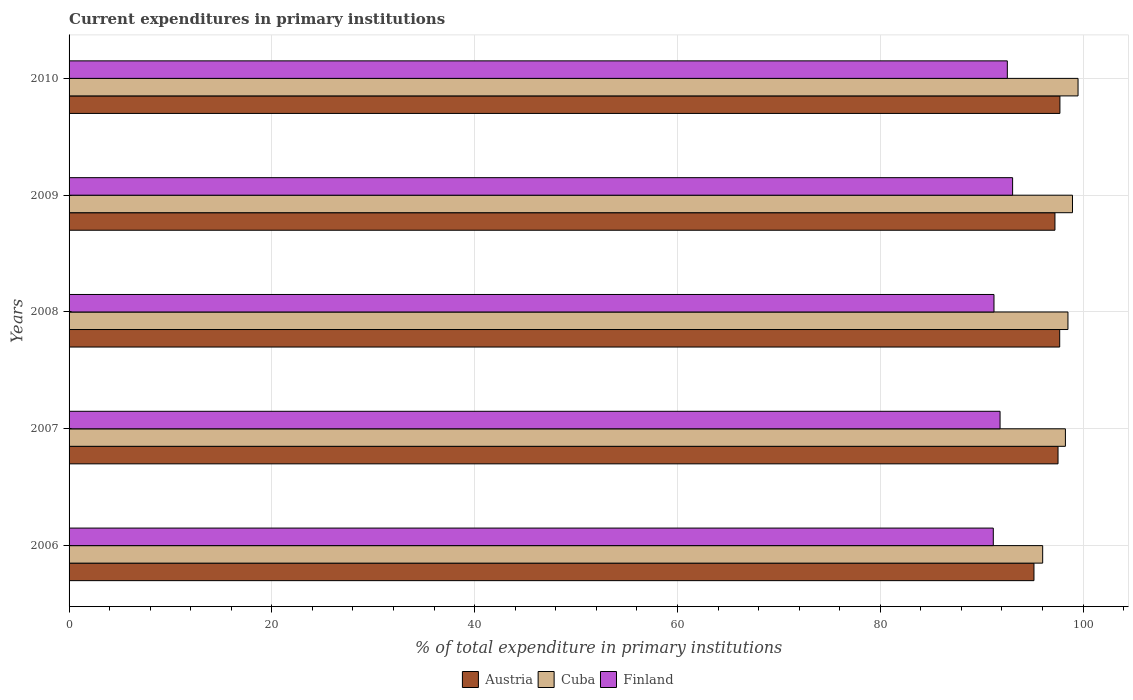Are the number of bars per tick equal to the number of legend labels?
Ensure brevity in your answer.  Yes. What is the current expenditures in primary institutions in Austria in 2006?
Give a very brief answer. 95.16. Across all years, what is the maximum current expenditures in primary institutions in Austria?
Offer a terse response. 97.72. Across all years, what is the minimum current expenditures in primary institutions in Austria?
Offer a terse response. 95.16. What is the total current expenditures in primary institutions in Cuba in the graph?
Provide a short and direct response. 491.24. What is the difference between the current expenditures in primary institutions in Cuba in 2006 and that in 2007?
Make the answer very short. -2.24. What is the difference between the current expenditures in primary institutions in Finland in 2006 and the current expenditures in primary institutions in Cuba in 2009?
Your answer should be compact. -7.81. What is the average current expenditures in primary institutions in Finland per year?
Your response must be concise. 91.95. In the year 2010, what is the difference between the current expenditures in primary institutions in Austria and current expenditures in primary institutions in Finland?
Make the answer very short. 5.19. In how many years, is the current expenditures in primary institutions in Finland greater than 84 %?
Offer a very short reply. 5. What is the ratio of the current expenditures in primary institutions in Cuba in 2006 to that in 2010?
Keep it short and to the point. 0.96. Is the difference between the current expenditures in primary institutions in Austria in 2007 and 2010 greater than the difference between the current expenditures in primary institutions in Finland in 2007 and 2010?
Ensure brevity in your answer.  Yes. What is the difference between the highest and the second highest current expenditures in primary institutions in Finland?
Provide a short and direct response. 0.52. What is the difference between the highest and the lowest current expenditures in primary institutions in Austria?
Your answer should be very brief. 2.56. In how many years, is the current expenditures in primary institutions in Austria greater than the average current expenditures in primary institutions in Austria taken over all years?
Offer a very short reply. 4. Is the sum of the current expenditures in primary institutions in Cuba in 2007 and 2009 greater than the maximum current expenditures in primary institutions in Finland across all years?
Offer a very short reply. Yes. What does the 2nd bar from the top in 2007 represents?
Your response must be concise. Cuba. What does the 3rd bar from the bottom in 2009 represents?
Give a very brief answer. Finland. Is it the case that in every year, the sum of the current expenditures in primary institutions in Austria and current expenditures in primary institutions in Cuba is greater than the current expenditures in primary institutions in Finland?
Offer a terse response. Yes. Are all the bars in the graph horizontal?
Your answer should be compact. Yes. How many years are there in the graph?
Provide a short and direct response. 5. What is the difference between two consecutive major ticks on the X-axis?
Ensure brevity in your answer.  20. Does the graph contain grids?
Provide a succinct answer. Yes. What is the title of the graph?
Offer a very short reply. Current expenditures in primary institutions. What is the label or title of the X-axis?
Keep it short and to the point. % of total expenditure in primary institutions. What is the label or title of the Y-axis?
Give a very brief answer. Years. What is the % of total expenditure in primary institutions in Austria in 2006?
Provide a succinct answer. 95.16. What is the % of total expenditure in primary institutions of Cuba in 2006?
Offer a very short reply. 96.02. What is the % of total expenditure in primary institutions in Finland in 2006?
Your response must be concise. 91.15. What is the % of total expenditure in primary institutions in Austria in 2007?
Keep it short and to the point. 97.53. What is the % of total expenditure in primary institutions of Cuba in 2007?
Your answer should be compact. 98.26. What is the % of total expenditure in primary institutions in Finland in 2007?
Offer a terse response. 91.81. What is the % of total expenditure in primary institutions in Austria in 2008?
Offer a terse response. 97.7. What is the % of total expenditure in primary institutions in Cuba in 2008?
Your answer should be compact. 98.51. What is the % of total expenditure in primary institutions in Finland in 2008?
Offer a very short reply. 91.21. What is the % of total expenditure in primary institutions of Austria in 2009?
Ensure brevity in your answer.  97.23. What is the % of total expenditure in primary institutions in Cuba in 2009?
Ensure brevity in your answer.  98.96. What is the % of total expenditure in primary institutions in Finland in 2009?
Give a very brief answer. 93.05. What is the % of total expenditure in primary institutions in Austria in 2010?
Make the answer very short. 97.72. What is the % of total expenditure in primary institutions in Cuba in 2010?
Provide a short and direct response. 99.5. What is the % of total expenditure in primary institutions in Finland in 2010?
Your response must be concise. 92.53. Across all years, what is the maximum % of total expenditure in primary institutions in Austria?
Ensure brevity in your answer.  97.72. Across all years, what is the maximum % of total expenditure in primary institutions of Cuba?
Provide a short and direct response. 99.5. Across all years, what is the maximum % of total expenditure in primary institutions in Finland?
Make the answer very short. 93.05. Across all years, what is the minimum % of total expenditure in primary institutions of Austria?
Offer a very short reply. 95.16. Across all years, what is the minimum % of total expenditure in primary institutions of Cuba?
Your response must be concise. 96.02. Across all years, what is the minimum % of total expenditure in primary institutions of Finland?
Provide a short and direct response. 91.15. What is the total % of total expenditure in primary institutions in Austria in the graph?
Offer a very short reply. 485.33. What is the total % of total expenditure in primary institutions in Cuba in the graph?
Give a very brief answer. 491.24. What is the total % of total expenditure in primary institutions of Finland in the graph?
Offer a very short reply. 459.75. What is the difference between the % of total expenditure in primary institutions in Austria in 2006 and that in 2007?
Provide a succinct answer. -2.37. What is the difference between the % of total expenditure in primary institutions in Cuba in 2006 and that in 2007?
Your response must be concise. -2.24. What is the difference between the % of total expenditure in primary institutions of Finland in 2006 and that in 2007?
Provide a succinct answer. -0.67. What is the difference between the % of total expenditure in primary institutions of Austria in 2006 and that in 2008?
Offer a very short reply. -2.54. What is the difference between the % of total expenditure in primary institutions of Cuba in 2006 and that in 2008?
Your answer should be very brief. -2.49. What is the difference between the % of total expenditure in primary institutions of Finland in 2006 and that in 2008?
Your answer should be very brief. -0.07. What is the difference between the % of total expenditure in primary institutions of Austria in 2006 and that in 2009?
Make the answer very short. -2.07. What is the difference between the % of total expenditure in primary institutions in Cuba in 2006 and that in 2009?
Your response must be concise. -2.94. What is the difference between the % of total expenditure in primary institutions in Finland in 2006 and that in 2009?
Ensure brevity in your answer.  -1.9. What is the difference between the % of total expenditure in primary institutions in Austria in 2006 and that in 2010?
Your answer should be compact. -2.56. What is the difference between the % of total expenditure in primary institutions of Cuba in 2006 and that in 2010?
Provide a short and direct response. -3.49. What is the difference between the % of total expenditure in primary institutions of Finland in 2006 and that in 2010?
Provide a succinct answer. -1.38. What is the difference between the % of total expenditure in primary institutions of Austria in 2007 and that in 2008?
Keep it short and to the point. -0.17. What is the difference between the % of total expenditure in primary institutions of Cuba in 2007 and that in 2008?
Make the answer very short. -0.25. What is the difference between the % of total expenditure in primary institutions of Finland in 2007 and that in 2008?
Keep it short and to the point. 0.6. What is the difference between the % of total expenditure in primary institutions in Austria in 2007 and that in 2009?
Provide a short and direct response. 0.3. What is the difference between the % of total expenditure in primary institutions of Cuba in 2007 and that in 2009?
Offer a terse response. -0.7. What is the difference between the % of total expenditure in primary institutions of Finland in 2007 and that in 2009?
Your answer should be compact. -1.24. What is the difference between the % of total expenditure in primary institutions of Austria in 2007 and that in 2010?
Keep it short and to the point. -0.19. What is the difference between the % of total expenditure in primary institutions in Cuba in 2007 and that in 2010?
Your response must be concise. -1.25. What is the difference between the % of total expenditure in primary institutions in Finland in 2007 and that in 2010?
Ensure brevity in your answer.  -0.72. What is the difference between the % of total expenditure in primary institutions of Austria in 2008 and that in 2009?
Provide a short and direct response. 0.47. What is the difference between the % of total expenditure in primary institutions in Cuba in 2008 and that in 2009?
Offer a very short reply. -0.45. What is the difference between the % of total expenditure in primary institutions in Finland in 2008 and that in 2009?
Keep it short and to the point. -1.84. What is the difference between the % of total expenditure in primary institutions of Austria in 2008 and that in 2010?
Keep it short and to the point. -0.02. What is the difference between the % of total expenditure in primary institutions of Cuba in 2008 and that in 2010?
Provide a short and direct response. -0.99. What is the difference between the % of total expenditure in primary institutions in Finland in 2008 and that in 2010?
Provide a succinct answer. -1.32. What is the difference between the % of total expenditure in primary institutions of Austria in 2009 and that in 2010?
Make the answer very short. -0.49. What is the difference between the % of total expenditure in primary institutions of Cuba in 2009 and that in 2010?
Offer a very short reply. -0.55. What is the difference between the % of total expenditure in primary institutions in Finland in 2009 and that in 2010?
Ensure brevity in your answer.  0.52. What is the difference between the % of total expenditure in primary institutions in Austria in 2006 and the % of total expenditure in primary institutions in Cuba in 2007?
Offer a terse response. -3.1. What is the difference between the % of total expenditure in primary institutions in Austria in 2006 and the % of total expenditure in primary institutions in Finland in 2007?
Provide a succinct answer. 3.34. What is the difference between the % of total expenditure in primary institutions in Cuba in 2006 and the % of total expenditure in primary institutions in Finland in 2007?
Keep it short and to the point. 4.2. What is the difference between the % of total expenditure in primary institutions in Austria in 2006 and the % of total expenditure in primary institutions in Cuba in 2008?
Your answer should be very brief. -3.35. What is the difference between the % of total expenditure in primary institutions of Austria in 2006 and the % of total expenditure in primary institutions of Finland in 2008?
Offer a terse response. 3.94. What is the difference between the % of total expenditure in primary institutions of Cuba in 2006 and the % of total expenditure in primary institutions of Finland in 2008?
Offer a terse response. 4.8. What is the difference between the % of total expenditure in primary institutions of Austria in 2006 and the % of total expenditure in primary institutions of Cuba in 2009?
Provide a short and direct response. -3.8. What is the difference between the % of total expenditure in primary institutions in Austria in 2006 and the % of total expenditure in primary institutions in Finland in 2009?
Ensure brevity in your answer.  2.11. What is the difference between the % of total expenditure in primary institutions in Cuba in 2006 and the % of total expenditure in primary institutions in Finland in 2009?
Ensure brevity in your answer.  2.97. What is the difference between the % of total expenditure in primary institutions of Austria in 2006 and the % of total expenditure in primary institutions of Cuba in 2010?
Keep it short and to the point. -4.35. What is the difference between the % of total expenditure in primary institutions in Austria in 2006 and the % of total expenditure in primary institutions in Finland in 2010?
Give a very brief answer. 2.63. What is the difference between the % of total expenditure in primary institutions of Cuba in 2006 and the % of total expenditure in primary institutions of Finland in 2010?
Offer a very short reply. 3.49. What is the difference between the % of total expenditure in primary institutions in Austria in 2007 and the % of total expenditure in primary institutions in Cuba in 2008?
Provide a succinct answer. -0.98. What is the difference between the % of total expenditure in primary institutions in Austria in 2007 and the % of total expenditure in primary institutions in Finland in 2008?
Offer a terse response. 6.32. What is the difference between the % of total expenditure in primary institutions of Cuba in 2007 and the % of total expenditure in primary institutions of Finland in 2008?
Your answer should be compact. 7.04. What is the difference between the % of total expenditure in primary institutions in Austria in 2007 and the % of total expenditure in primary institutions in Cuba in 2009?
Provide a succinct answer. -1.43. What is the difference between the % of total expenditure in primary institutions in Austria in 2007 and the % of total expenditure in primary institutions in Finland in 2009?
Ensure brevity in your answer.  4.48. What is the difference between the % of total expenditure in primary institutions of Cuba in 2007 and the % of total expenditure in primary institutions of Finland in 2009?
Give a very brief answer. 5.21. What is the difference between the % of total expenditure in primary institutions in Austria in 2007 and the % of total expenditure in primary institutions in Cuba in 2010?
Make the answer very short. -1.97. What is the difference between the % of total expenditure in primary institutions of Austria in 2007 and the % of total expenditure in primary institutions of Finland in 2010?
Give a very brief answer. 5. What is the difference between the % of total expenditure in primary institutions of Cuba in 2007 and the % of total expenditure in primary institutions of Finland in 2010?
Make the answer very short. 5.73. What is the difference between the % of total expenditure in primary institutions of Austria in 2008 and the % of total expenditure in primary institutions of Cuba in 2009?
Your answer should be very brief. -1.26. What is the difference between the % of total expenditure in primary institutions in Austria in 2008 and the % of total expenditure in primary institutions in Finland in 2009?
Offer a terse response. 4.64. What is the difference between the % of total expenditure in primary institutions of Cuba in 2008 and the % of total expenditure in primary institutions of Finland in 2009?
Your response must be concise. 5.46. What is the difference between the % of total expenditure in primary institutions in Austria in 2008 and the % of total expenditure in primary institutions in Cuba in 2010?
Offer a very short reply. -1.81. What is the difference between the % of total expenditure in primary institutions in Austria in 2008 and the % of total expenditure in primary institutions in Finland in 2010?
Your response must be concise. 5.16. What is the difference between the % of total expenditure in primary institutions of Cuba in 2008 and the % of total expenditure in primary institutions of Finland in 2010?
Ensure brevity in your answer.  5.98. What is the difference between the % of total expenditure in primary institutions of Austria in 2009 and the % of total expenditure in primary institutions of Cuba in 2010?
Keep it short and to the point. -2.28. What is the difference between the % of total expenditure in primary institutions in Austria in 2009 and the % of total expenditure in primary institutions in Finland in 2010?
Make the answer very short. 4.7. What is the difference between the % of total expenditure in primary institutions of Cuba in 2009 and the % of total expenditure in primary institutions of Finland in 2010?
Your answer should be compact. 6.42. What is the average % of total expenditure in primary institutions in Austria per year?
Provide a short and direct response. 97.07. What is the average % of total expenditure in primary institutions of Cuba per year?
Your response must be concise. 98.25. What is the average % of total expenditure in primary institutions of Finland per year?
Give a very brief answer. 91.95. In the year 2006, what is the difference between the % of total expenditure in primary institutions in Austria and % of total expenditure in primary institutions in Cuba?
Keep it short and to the point. -0.86. In the year 2006, what is the difference between the % of total expenditure in primary institutions of Austria and % of total expenditure in primary institutions of Finland?
Your response must be concise. 4.01. In the year 2006, what is the difference between the % of total expenditure in primary institutions of Cuba and % of total expenditure in primary institutions of Finland?
Offer a very short reply. 4.87. In the year 2007, what is the difference between the % of total expenditure in primary institutions of Austria and % of total expenditure in primary institutions of Cuba?
Your answer should be very brief. -0.73. In the year 2007, what is the difference between the % of total expenditure in primary institutions in Austria and % of total expenditure in primary institutions in Finland?
Give a very brief answer. 5.72. In the year 2007, what is the difference between the % of total expenditure in primary institutions of Cuba and % of total expenditure in primary institutions of Finland?
Keep it short and to the point. 6.44. In the year 2008, what is the difference between the % of total expenditure in primary institutions of Austria and % of total expenditure in primary institutions of Cuba?
Keep it short and to the point. -0.81. In the year 2008, what is the difference between the % of total expenditure in primary institutions of Austria and % of total expenditure in primary institutions of Finland?
Your answer should be very brief. 6.48. In the year 2008, what is the difference between the % of total expenditure in primary institutions of Cuba and % of total expenditure in primary institutions of Finland?
Your answer should be very brief. 7.3. In the year 2009, what is the difference between the % of total expenditure in primary institutions of Austria and % of total expenditure in primary institutions of Cuba?
Keep it short and to the point. -1.73. In the year 2009, what is the difference between the % of total expenditure in primary institutions of Austria and % of total expenditure in primary institutions of Finland?
Offer a very short reply. 4.18. In the year 2009, what is the difference between the % of total expenditure in primary institutions in Cuba and % of total expenditure in primary institutions in Finland?
Your answer should be compact. 5.9. In the year 2010, what is the difference between the % of total expenditure in primary institutions in Austria and % of total expenditure in primary institutions in Cuba?
Provide a short and direct response. -1.79. In the year 2010, what is the difference between the % of total expenditure in primary institutions in Austria and % of total expenditure in primary institutions in Finland?
Your answer should be very brief. 5.19. In the year 2010, what is the difference between the % of total expenditure in primary institutions of Cuba and % of total expenditure in primary institutions of Finland?
Your response must be concise. 6.97. What is the ratio of the % of total expenditure in primary institutions in Austria in 2006 to that in 2007?
Offer a very short reply. 0.98. What is the ratio of the % of total expenditure in primary institutions in Cuba in 2006 to that in 2007?
Give a very brief answer. 0.98. What is the ratio of the % of total expenditure in primary institutions in Finland in 2006 to that in 2007?
Your answer should be very brief. 0.99. What is the ratio of the % of total expenditure in primary institutions in Austria in 2006 to that in 2008?
Your response must be concise. 0.97. What is the ratio of the % of total expenditure in primary institutions in Cuba in 2006 to that in 2008?
Give a very brief answer. 0.97. What is the ratio of the % of total expenditure in primary institutions in Austria in 2006 to that in 2009?
Give a very brief answer. 0.98. What is the ratio of the % of total expenditure in primary institutions in Cuba in 2006 to that in 2009?
Your response must be concise. 0.97. What is the ratio of the % of total expenditure in primary institutions in Finland in 2006 to that in 2009?
Your answer should be compact. 0.98. What is the ratio of the % of total expenditure in primary institutions of Austria in 2006 to that in 2010?
Provide a succinct answer. 0.97. What is the ratio of the % of total expenditure in primary institutions in Cuba in 2006 to that in 2010?
Offer a very short reply. 0.96. What is the ratio of the % of total expenditure in primary institutions in Finland in 2006 to that in 2010?
Keep it short and to the point. 0.98. What is the ratio of the % of total expenditure in primary institutions of Finland in 2007 to that in 2008?
Offer a terse response. 1.01. What is the ratio of the % of total expenditure in primary institutions in Austria in 2007 to that in 2009?
Provide a short and direct response. 1. What is the ratio of the % of total expenditure in primary institutions in Finland in 2007 to that in 2009?
Ensure brevity in your answer.  0.99. What is the ratio of the % of total expenditure in primary institutions in Cuba in 2007 to that in 2010?
Your answer should be compact. 0.99. What is the ratio of the % of total expenditure in primary institutions of Finland in 2007 to that in 2010?
Give a very brief answer. 0.99. What is the ratio of the % of total expenditure in primary institutions in Austria in 2008 to that in 2009?
Keep it short and to the point. 1. What is the ratio of the % of total expenditure in primary institutions of Finland in 2008 to that in 2009?
Give a very brief answer. 0.98. What is the ratio of the % of total expenditure in primary institutions in Cuba in 2008 to that in 2010?
Make the answer very short. 0.99. What is the ratio of the % of total expenditure in primary institutions of Finland in 2008 to that in 2010?
Provide a short and direct response. 0.99. What is the ratio of the % of total expenditure in primary institutions in Cuba in 2009 to that in 2010?
Offer a very short reply. 0.99. What is the ratio of the % of total expenditure in primary institutions in Finland in 2009 to that in 2010?
Provide a short and direct response. 1.01. What is the difference between the highest and the second highest % of total expenditure in primary institutions of Austria?
Give a very brief answer. 0.02. What is the difference between the highest and the second highest % of total expenditure in primary institutions of Cuba?
Offer a terse response. 0.55. What is the difference between the highest and the second highest % of total expenditure in primary institutions in Finland?
Keep it short and to the point. 0.52. What is the difference between the highest and the lowest % of total expenditure in primary institutions in Austria?
Provide a succinct answer. 2.56. What is the difference between the highest and the lowest % of total expenditure in primary institutions in Cuba?
Offer a very short reply. 3.49. What is the difference between the highest and the lowest % of total expenditure in primary institutions in Finland?
Ensure brevity in your answer.  1.9. 